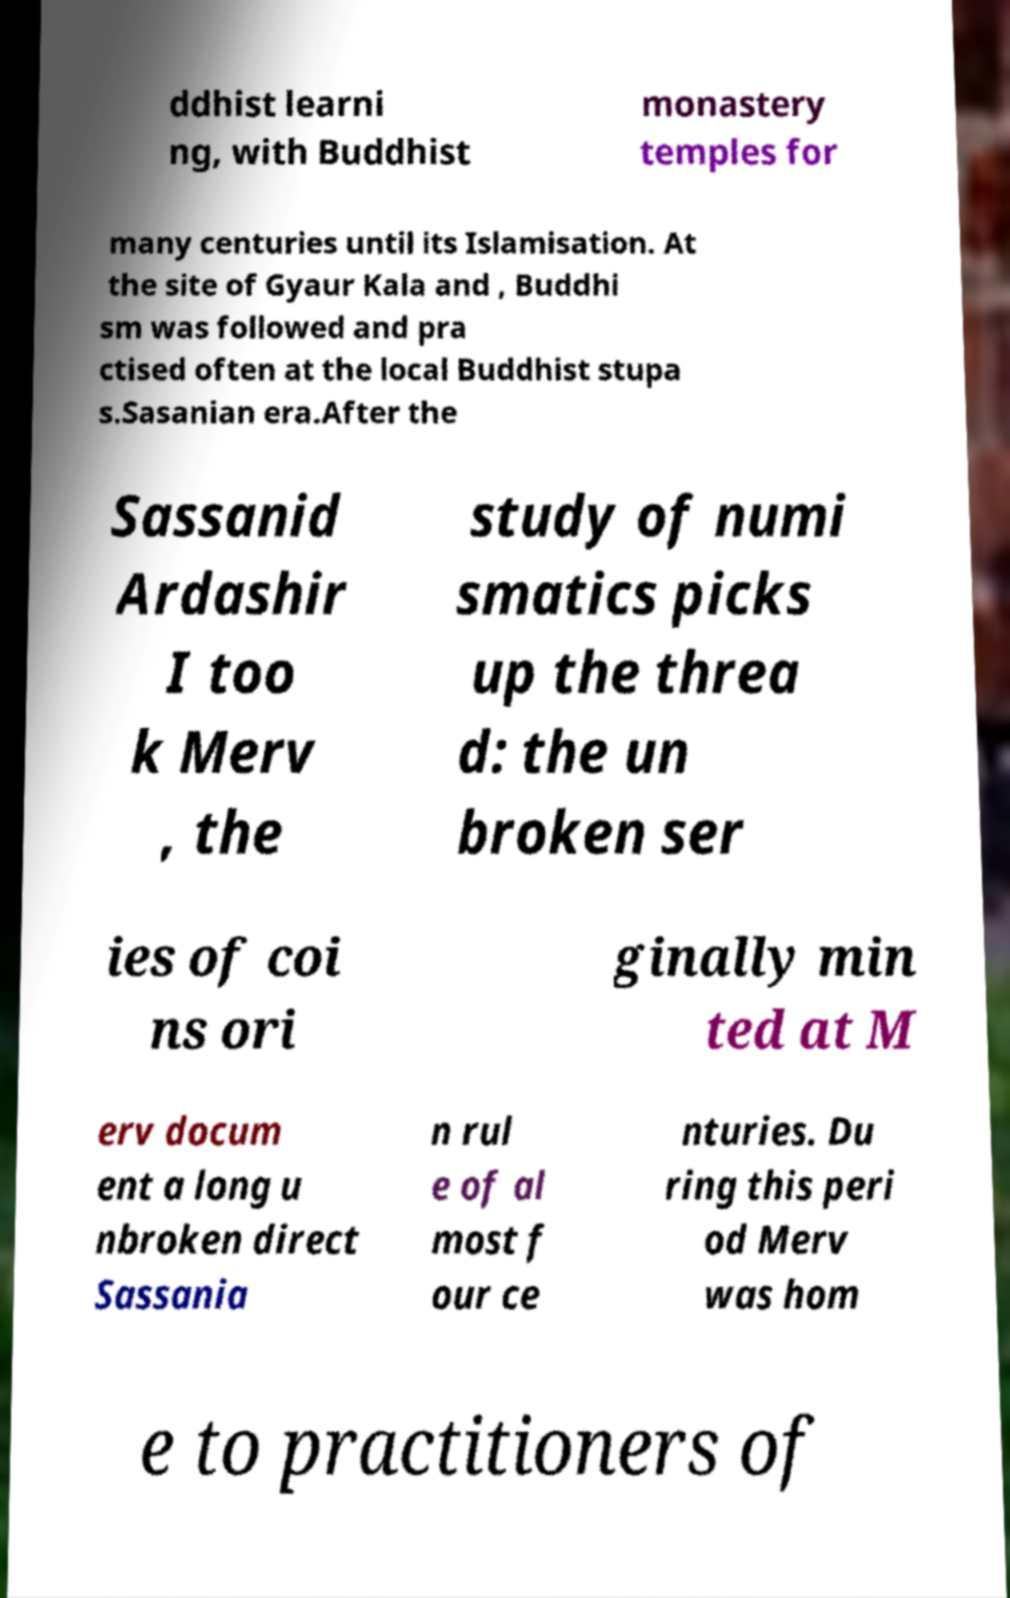Please identify and transcribe the text found in this image. ddhist learni ng, with Buddhist monastery temples for many centuries until its Islamisation. At the site of Gyaur Kala and , Buddhi sm was followed and pra ctised often at the local Buddhist stupa s.Sasanian era.After the Sassanid Ardashir I too k Merv , the study of numi smatics picks up the threa d: the un broken ser ies of coi ns ori ginally min ted at M erv docum ent a long u nbroken direct Sassania n rul e of al most f our ce nturies. Du ring this peri od Merv was hom e to practitioners of 